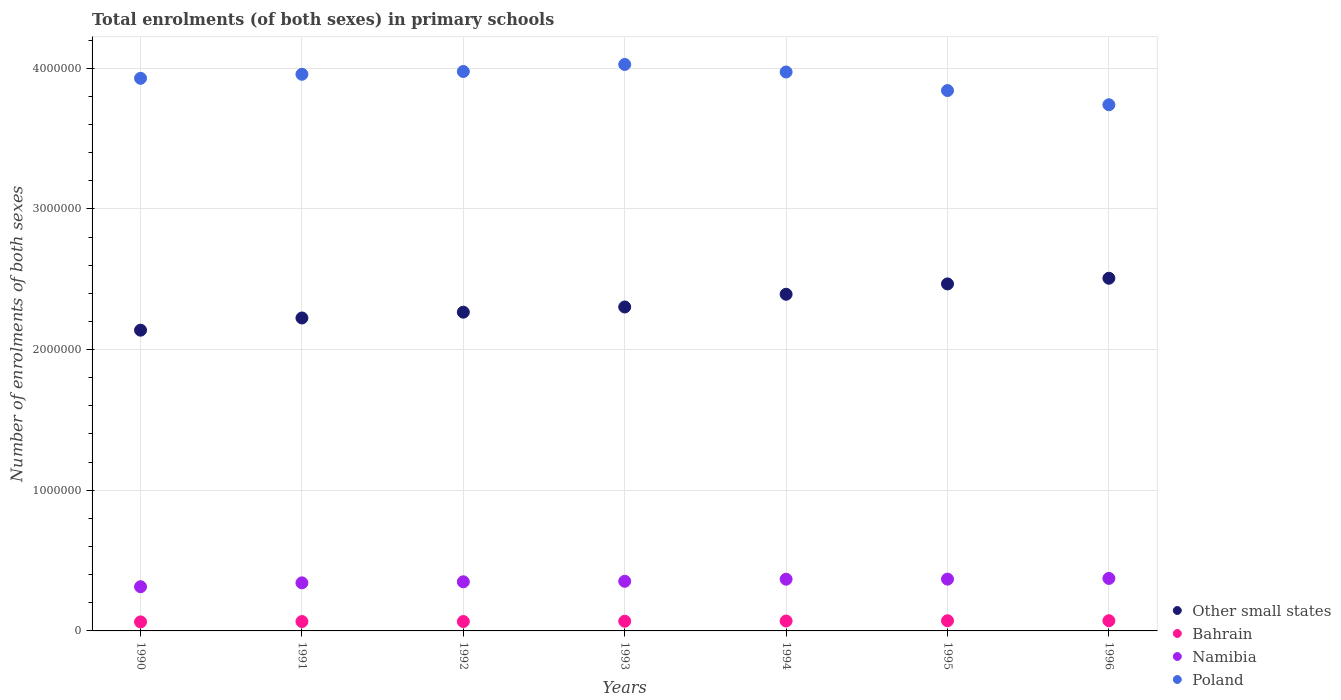How many different coloured dotlines are there?
Offer a terse response. 4. Is the number of dotlines equal to the number of legend labels?
Your answer should be very brief. Yes. What is the number of enrolments in primary schools in Poland in 1992?
Your answer should be very brief. 3.98e+06. Across all years, what is the maximum number of enrolments in primary schools in Namibia?
Keep it short and to the point. 3.73e+05. Across all years, what is the minimum number of enrolments in primary schools in Bahrain?
Ensure brevity in your answer.  6.40e+04. In which year was the number of enrolments in primary schools in Namibia minimum?
Provide a short and direct response. 1990. What is the total number of enrolments in primary schools in Other small states in the graph?
Offer a terse response. 1.63e+07. What is the difference between the number of enrolments in primary schools in Other small states in 1991 and that in 1994?
Your response must be concise. -1.69e+05. What is the difference between the number of enrolments in primary schools in Namibia in 1992 and the number of enrolments in primary schools in Other small states in 1995?
Your response must be concise. -2.12e+06. What is the average number of enrolments in primary schools in Namibia per year?
Provide a short and direct response. 3.52e+05. In the year 1995, what is the difference between the number of enrolments in primary schools in Bahrain and number of enrolments in primary schools in Namibia?
Keep it short and to the point. -2.96e+05. In how many years, is the number of enrolments in primary schools in Other small states greater than 1400000?
Make the answer very short. 7. What is the ratio of the number of enrolments in primary schools in Other small states in 1994 to that in 1996?
Give a very brief answer. 0.95. Is the difference between the number of enrolments in primary schools in Bahrain in 1995 and 1996 greater than the difference between the number of enrolments in primary schools in Namibia in 1995 and 1996?
Give a very brief answer. Yes. What is the difference between the highest and the second highest number of enrolments in primary schools in Bahrain?
Provide a succinct answer. 197. What is the difference between the highest and the lowest number of enrolments in primary schools in Bahrain?
Your answer should be compact. 8526. In how many years, is the number of enrolments in primary schools in Bahrain greater than the average number of enrolments in primary schools in Bahrain taken over all years?
Your response must be concise. 4. Is the sum of the number of enrolments in primary schools in Namibia in 1990 and 1993 greater than the maximum number of enrolments in primary schools in Poland across all years?
Offer a very short reply. No. Is the number of enrolments in primary schools in Bahrain strictly greater than the number of enrolments in primary schools in Other small states over the years?
Make the answer very short. No. Is the number of enrolments in primary schools in Other small states strictly less than the number of enrolments in primary schools in Bahrain over the years?
Ensure brevity in your answer.  No. How many dotlines are there?
Offer a terse response. 4. How many years are there in the graph?
Your answer should be compact. 7. Does the graph contain any zero values?
Make the answer very short. No. Does the graph contain grids?
Ensure brevity in your answer.  Yes. Where does the legend appear in the graph?
Offer a very short reply. Bottom right. What is the title of the graph?
Your answer should be compact. Total enrolments (of both sexes) in primary schools. Does "Curacao" appear as one of the legend labels in the graph?
Your response must be concise. No. What is the label or title of the X-axis?
Keep it short and to the point. Years. What is the label or title of the Y-axis?
Offer a very short reply. Number of enrolments of both sexes. What is the Number of enrolments of both sexes of Other small states in 1990?
Offer a very short reply. 2.14e+06. What is the Number of enrolments of both sexes in Bahrain in 1990?
Give a very brief answer. 6.40e+04. What is the Number of enrolments of both sexes in Namibia in 1990?
Make the answer very short. 3.14e+05. What is the Number of enrolments of both sexes in Poland in 1990?
Your response must be concise. 3.93e+06. What is the Number of enrolments of both sexes in Other small states in 1991?
Make the answer very short. 2.22e+06. What is the Number of enrolments of both sexes of Bahrain in 1991?
Your response must be concise. 6.66e+04. What is the Number of enrolments of both sexes in Namibia in 1991?
Provide a succinct answer. 3.42e+05. What is the Number of enrolments of both sexes in Poland in 1991?
Offer a terse response. 3.96e+06. What is the Number of enrolments of both sexes in Other small states in 1992?
Your answer should be very brief. 2.27e+06. What is the Number of enrolments of both sexes in Bahrain in 1992?
Offer a terse response. 6.67e+04. What is the Number of enrolments of both sexes of Namibia in 1992?
Your answer should be very brief. 3.49e+05. What is the Number of enrolments of both sexes of Poland in 1992?
Provide a short and direct response. 3.98e+06. What is the Number of enrolments of both sexes in Other small states in 1993?
Offer a very short reply. 2.30e+06. What is the Number of enrolments of both sexes in Bahrain in 1993?
Ensure brevity in your answer.  6.89e+04. What is the Number of enrolments of both sexes of Namibia in 1993?
Your answer should be compact. 3.53e+05. What is the Number of enrolments of both sexes of Poland in 1993?
Provide a succinct answer. 4.03e+06. What is the Number of enrolments of both sexes in Other small states in 1994?
Ensure brevity in your answer.  2.39e+06. What is the Number of enrolments of both sexes of Bahrain in 1994?
Keep it short and to the point. 7.05e+04. What is the Number of enrolments of both sexes in Namibia in 1994?
Make the answer very short. 3.68e+05. What is the Number of enrolments of both sexes of Poland in 1994?
Ensure brevity in your answer.  3.97e+06. What is the Number of enrolments of both sexes of Other small states in 1995?
Your response must be concise. 2.47e+06. What is the Number of enrolments of both sexes in Bahrain in 1995?
Your response must be concise. 7.23e+04. What is the Number of enrolments of both sexes in Namibia in 1995?
Your response must be concise. 3.68e+05. What is the Number of enrolments of both sexes in Poland in 1995?
Offer a terse response. 3.84e+06. What is the Number of enrolments of both sexes in Other small states in 1996?
Provide a short and direct response. 2.51e+06. What is the Number of enrolments of both sexes in Bahrain in 1996?
Offer a terse response. 7.25e+04. What is the Number of enrolments of both sexes of Namibia in 1996?
Give a very brief answer. 3.73e+05. What is the Number of enrolments of both sexes of Poland in 1996?
Your answer should be compact. 3.74e+06. Across all years, what is the maximum Number of enrolments of both sexes in Other small states?
Make the answer very short. 2.51e+06. Across all years, what is the maximum Number of enrolments of both sexes in Bahrain?
Your answer should be very brief. 7.25e+04. Across all years, what is the maximum Number of enrolments of both sexes in Namibia?
Provide a succinct answer. 3.73e+05. Across all years, what is the maximum Number of enrolments of both sexes of Poland?
Offer a terse response. 4.03e+06. Across all years, what is the minimum Number of enrolments of both sexes of Other small states?
Offer a terse response. 2.14e+06. Across all years, what is the minimum Number of enrolments of both sexes in Bahrain?
Your answer should be compact. 6.40e+04. Across all years, what is the minimum Number of enrolments of both sexes in Namibia?
Your response must be concise. 3.14e+05. Across all years, what is the minimum Number of enrolments of both sexes of Poland?
Make the answer very short. 3.74e+06. What is the total Number of enrolments of both sexes in Other small states in the graph?
Make the answer very short. 1.63e+07. What is the total Number of enrolments of both sexes in Bahrain in the graph?
Give a very brief answer. 4.82e+05. What is the total Number of enrolments of both sexes in Namibia in the graph?
Make the answer very short. 2.47e+06. What is the total Number of enrolments of both sexes of Poland in the graph?
Your answer should be very brief. 2.74e+07. What is the difference between the Number of enrolments of both sexes of Other small states in 1990 and that in 1991?
Give a very brief answer. -8.66e+04. What is the difference between the Number of enrolments of both sexes in Bahrain in 1990 and that in 1991?
Keep it short and to the point. -2597. What is the difference between the Number of enrolments of both sexes in Namibia in 1990 and that in 1991?
Ensure brevity in your answer.  -2.76e+04. What is the difference between the Number of enrolments of both sexes of Poland in 1990 and that in 1991?
Your answer should be compact. -2.87e+04. What is the difference between the Number of enrolments of both sexes in Other small states in 1990 and that in 1992?
Provide a short and direct response. -1.28e+05. What is the difference between the Number of enrolments of both sexes of Bahrain in 1990 and that in 1992?
Your response must be concise. -2694. What is the difference between the Number of enrolments of both sexes of Namibia in 1990 and that in 1992?
Your answer should be very brief. -3.51e+04. What is the difference between the Number of enrolments of both sexes of Poland in 1990 and that in 1992?
Your response must be concise. -4.83e+04. What is the difference between the Number of enrolments of both sexes of Other small states in 1990 and that in 1993?
Your answer should be compact. -1.65e+05. What is the difference between the Number of enrolments of both sexes in Bahrain in 1990 and that in 1993?
Offer a terse response. -4898. What is the difference between the Number of enrolments of both sexes of Namibia in 1990 and that in 1993?
Give a very brief answer. -3.88e+04. What is the difference between the Number of enrolments of both sexes in Poland in 1990 and that in 1993?
Ensure brevity in your answer.  -9.85e+04. What is the difference between the Number of enrolments of both sexes of Other small states in 1990 and that in 1994?
Make the answer very short. -2.55e+05. What is the difference between the Number of enrolments of both sexes in Bahrain in 1990 and that in 1994?
Offer a very short reply. -6513. What is the difference between the Number of enrolments of both sexes in Namibia in 1990 and that in 1994?
Make the answer very short. -5.36e+04. What is the difference between the Number of enrolments of both sexes of Poland in 1990 and that in 1994?
Your answer should be very brief. -4.49e+04. What is the difference between the Number of enrolments of both sexes of Other small states in 1990 and that in 1995?
Your answer should be compact. -3.29e+05. What is the difference between the Number of enrolments of both sexes in Bahrain in 1990 and that in 1995?
Offer a terse response. -8329. What is the difference between the Number of enrolments of both sexes of Namibia in 1990 and that in 1995?
Ensure brevity in your answer.  -5.41e+04. What is the difference between the Number of enrolments of both sexes of Poland in 1990 and that in 1995?
Keep it short and to the point. 8.71e+04. What is the difference between the Number of enrolments of both sexes of Other small states in 1990 and that in 1996?
Your answer should be very brief. -3.69e+05. What is the difference between the Number of enrolments of both sexes of Bahrain in 1990 and that in 1996?
Make the answer very short. -8526. What is the difference between the Number of enrolments of both sexes in Namibia in 1990 and that in 1996?
Offer a very short reply. -5.92e+04. What is the difference between the Number of enrolments of both sexes of Poland in 1990 and that in 1996?
Offer a very short reply. 1.88e+05. What is the difference between the Number of enrolments of both sexes of Other small states in 1991 and that in 1992?
Provide a succinct answer. -4.13e+04. What is the difference between the Number of enrolments of both sexes in Bahrain in 1991 and that in 1992?
Your answer should be very brief. -97. What is the difference between the Number of enrolments of both sexes in Namibia in 1991 and that in 1992?
Give a very brief answer. -7466. What is the difference between the Number of enrolments of both sexes of Poland in 1991 and that in 1992?
Give a very brief answer. -1.96e+04. What is the difference between the Number of enrolments of both sexes in Other small states in 1991 and that in 1993?
Offer a very short reply. -7.82e+04. What is the difference between the Number of enrolments of both sexes in Bahrain in 1991 and that in 1993?
Your response must be concise. -2301. What is the difference between the Number of enrolments of both sexes in Namibia in 1991 and that in 1993?
Give a very brief answer. -1.12e+04. What is the difference between the Number of enrolments of both sexes of Poland in 1991 and that in 1993?
Provide a short and direct response. -6.98e+04. What is the difference between the Number of enrolments of both sexes of Other small states in 1991 and that in 1994?
Provide a succinct answer. -1.69e+05. What is the difference between the Number of enrolments of both sexes in Bahrain in 1991 and that in 1994?
Provide a succinct answer. -3916. What is the difference between the Number of enrolments of both sexes in Namibia in 1991 and that in 1994?
Provide a succinct answer. -2.60e+04. What is the difference between the Number of enrolments of both sexes in Poland in 1991 and that in 1994?
Provide a succinct answer. -1.62e+04. What is the difference between the Number of enrolments of both sexes in Other small states in 1991 and that in 1995?
Offer a terse response. -2.42e+05. What is the difference between the Number of enrolments of both sexes in Bahrain in 1991 and that in 1995?
Offer a very short reply. -5732. What is the difference between the Number of enrolments of both sexes in Namibia in 1991 and that in 1995?
Offer a very short reply. -2.65e+04. What is the difference between the Number of enrolments of both sexes of Poland in 1991 and that in 1995?
Provide a short and direct response. 1.16e+05. What is the difference between the Number of enrolments of both sexes of Other small states in 1991 and that in 1996?
Ensure brevity in your answer.  -2.82e+05. What is the difference between the Number of enrolments of both sexes in Bahrain in 1991 and that in 1996?
Give a very brief answer. -5929. What is the difference between the Number of enrolments of both sexes of Namibia in 1991 and that in 1996?
Offer a very short reply. -3.16e+04. What is the difference between the Number of enrolments of both sexes of Poland in 1991 and that in 1996?
Keep it short and to the point. 2.17e+05. What is the difference between the Number of enrolments of both sexes of Other small states in 1992 and that in 1993?
Your response must be concise. -3.69e+04. What is the difference between the Number of enrolments of both sexes of Bahrain in 1992 and that in 1993?
Keep it short and to the point. -2204. What is the difference between the Number of enrolments of both sexes in Namibia in 1992 and that in 1993?
Your answer should be compact. -3733. What is the difference between the Number of enrolments of both sexes in Poland in 1992 and that in 1993?
Your answer should be very brief. -5.02e+04. What is the difference between the Number of enrolments of both sexes of Other small states in 1992 and that in 1994?
Provide a succinct answer. -1.27e+05. What is the difference between the Number of enrolments of both sexes of Bahrain in 1992 and that in 1994?
Make the answer very short. -3819. What is the difference between the Number of enrolments of both sexes in Namibia in 1992 and that in 1994?
Your response must be concise. -1.85e+04. What is the difference between the Number of enrolments of both sexes in Poland in 1992 and that in 1994?
Make the answer very short. 3444. What is the difference between the Number of enrolments of both sexes in Other small states in 1992 and that in 1995?
Provide a succinct answer. -2.01e+05. What is the difference between the Number of enrolments of both sexes in Bahrain in 1992 and that in 1995?
Provide a succinct answer. -5635. What is the difference between the Number of enrolments of both sexes in Namibia in 1992 and that in 1995?
Your answer should be very brief. -1.91e+04. What is the difference between the Number of enrolments of both sexes in Poland in 1992 and that in 1995?
Your response must be concise. 1.35e+05. What is the difference between the Number of enrolments of both sexes in Other small states in 1992 and that in 1996?
Provide a succinct answer. -2.41e+05. What is the difference between the Number of enrolments of both sexes of Bahrain in 1992 and that in 1996?
Ensure brevity in your answer.  -5832. What is the difference between the Number of enrolments of both sexes in Namibia in 1992 and that in 1996?
Give a very brief answer. -2.41e+04. What is the difference between the Number of enrolments of both sexes in Poland in 1992 and that in 1996?
Ensure brevity in your answer.  2.36e+05. What is the difference between the Number of enrolments of both sexes in Other small states in 1993 and that in 1994?
Offer a very short reply. -9.05e+04. What is the difference between the Number of enrolments of both sexes of Bahrain in 1993 and that in 1994?
Offer a very short reply. -1615. What is the difference between the Number of enrolments of both sexes of Namibia in 1993 and that in 1994?
Ensure brevity in your answer.  -1.48e+04. What is the difference between the Number of enrolments of both sexes in Poland in 1993 and that in 1994?
Ensure brevity in your answer.  5.36e+04. What is the difference between the Number of enrolments of both sexes in Other small states in 1993 and that in 1995?
Your answer should be compact. -1.64e+05. What is the difference between the Number of enrolments of both sexes in Bahrain in 1993 and that in 1995?
Ensure brevity in your answer.  -3431. What is the difference between the Number of enrolments of both sexes in Namibia in 1993 and that in 1995?
Offer a terse response. -1.53e+04. What is the difference between the Number of enrolments of both sexes of Poland in 1993 and that in 1995?
Keep it short and to the point. 1.86e+05. What is the difference between the Number of enrolments of both sexes of Other small states in 1993 and that in 1996?
Offer a very short reply. -2.04e+05. What is the difference between the Number of enrolments of both sexes of Bahrain in 1993 and that in 1996?
Give a very brief answer. -3628. What is the difference between the Number of enrolments of both sexes in Namibia in 1993 and that in 1996?
Make the answer very short. -2.04e+04. What is the difference between the Number of enrolments of both sexes in Poland in 1993 and that in 1996?
Keep it short and to the point. 2.87e+05. What is the difference between the Number of enrolments of both sexes in Other small states in 1994 and that in 1995?
Keep it short and to the point. -7.35e+04. What is the difference between the Number of enrolments of both sexes in Bahrain in 1994 and that in 1995?
Provide a succinct answer. -1816. What is the difference between the Number of enrolments of both sexes of Namibia in 1994 and that in 1995?
Offer a terse response. -553. What is the difference between the Number of enrolments of both sexes in Poland in 1994 and that in 1995?
Provide a succinct answer. 1.32e+05. What is the difference between the Number of enrolments of both sexes in Other small states in 1994 and that in 1996?
Your response must be concise. -1.14e+05. What is the difference between the Number of enrolments of both sexes in Bahrain in 1994 and that in 1996?
Ensure brevity in your answer.  -2013. What is the difference between the Number of enrolments of both sexes of Namibia in 1994 and that in 1996?
Provide a succinct answer. -5607. What is the difference between the Number of enrolments of both sexes of Poland in 1994 and that in 1996?
Offer a terse response. 2.33e+05. What is the difference between the Number of enrolments of both sexes of Other small states in 1995 and that in 1996?
Provide a succinct answer. -4.03e+04. What is the difference between the Number of enrolments of both sexes of Bahrain in 1995 and that in 1996?
Offer a terse response. -197. What is the difference between the Number of enrolments of both sexes in Namibia in 1995 and that in 1996?
Ensure brevity in your answer.  -5054. What is the difference between the Number of enrolments of both sexes in Poland in 1995 and that in 1996?
Keep it short and to the point. 1.01e+05. What is the difference between the Number of enrolments of both sexes in Other small states in 1990 and the Number of enrolments of both sexes in Bahrain in 1991?
Provide a short and direct response. 2.07e+06. What is the difference between the Number of enrolments of both sexes of Other small states in 1990 and the Number of enrolments of both sexes of Namibia in 1991?
Keep it short and to the point. 1.80e+06. What is the difference between the Number of enrolments of both sexes of Other small states in 1990 and the Number of enrolments of both sexes of Poland in 1991?
Offer a terse response. -1.82e+06. What is the difference between the Number of enrolments of both sexes of Bahrain in 1990 and the Number of enrolments of both sexes of Namibia in 1991?
Offer a terse response. -2.78e+05. What is the difference between the Number of enrolments of both sexes of Bahrain in 1990 and the Number of enrolments of both sexes of Poland in 1991?
Provide a short and direct response. -3.89e+06. What is the difference between the Number of enrolments of both sexes in Namibia in 1990 and the Number of enrolments of both sexes in Poland in 1991?
Your response must be concise. -3.64e+06. What is the difference between the Number of enrolments of both sexes of Other small states in 1990 and the Number of enrolments of both sexes of Bahrain in 1992?
Offer a terse response. 2.07e+06. What is the difference between the Number of enrolments of both sexes of Other small states in 1990 and the Number of enrolments of both sexes of Namibia in 1992?
Make the answer very short. 1.79e+06. What is the difference between the Number of enrolments of both sexes in Other small states in 1990 and the Number of enrolments of both sexes in Poland in 1992?
Ensure brevity in your answer.  -1.84e+06. What is the difference between the Number of enrolments of both sexes in Bahrain in 1990 and the Number of enrolments of both sexes in Namibia in 1992?
Make the answer very short. -2.85e+05. What is the difference between the Number of enrolments of both sexes of Bahrain in 1990 and the Number of enrolments of both sexes of Poland in 1992?
Your response must be concise. -3.91e+06. What is the difference between the Number of enrolments of both sexes of Namibia in 1990 and the Number of enrolments of both sexes of Poland in 1992?
Ensure brevity in your answer.  -3.66e+06. What is the difference between the Number of enrolments of both sexes in Other small states in 1990 and the Number of enrolments of both sexes in Bahrain in 1993?
Provide a short and direct response. 2.07e+06. What is the difference between the Number of enrolments of both sexes of Other small states in 1990 and the Number of enrolments of both sexes of Namibia in 1993?
Offer a terse response. 1.79e+06. What is the difference between the Number of enrolments of both sexes of Other small states in 1990 and the Number of enrolments of both sexes of Poland in 1993?
Ensure brevity in your answer.  -1.89e+06. What is the difference between the Number of enrolments of both sexes of Bahrain in 1990 and the Number of enrolments of both sexes of Namibia in 1993?
Your answer should be very brief. -2.89e+05. What is the difference between the Number of enrolments of both sexes of Bahrain in 1990 and the Number of enrolments of both sexes of Poland in 1993?
Give a very brief answer. -3.96e+06. What is the difference between the Number of enrolments of both sexes of Namibia in 1990 and the Number of enrolments of both sexes of Poland in 1993?
Your response must be concise. -3.71e+06. What is the difference between the Number of enrolments of both sexes of Other small states in 1990 and the Number of enrolments of both sexes of Bahrain in 1994?
Your answer should be compact. 2.07e+06. What is the difference between the Number of enrolments of both sexes of Other small states in 1990 and the Number of enrolments of both sexes of Namibia in 1994?
Your answer should be compact. 1.77e+06. What is the difference between the Number of enrolments of both sexes in Other small states in 1990 and the Number of enrolments of both sexes in Poland in 1994?
Keep it short and to the point. -1.84e+06. What is the difference between the Number of enrolments of both sexes in Bahrain in 1990 and the Number of enrolments of both sexes in Namibia in 1994?
Keep it short and to the point. -3.04e+05. What is the difference between the Number of enrolments of both sexes of Bahrain in 1990 and the Number of enrolments of both sexes of Poland in 1994?
Ensure brevity in your answer.  -3.91e+06. What is the difference between the Number of enrolments of both sexes in Namibia in 1990 and the Number of enrolments of both sexes in Poland in 1994?
Ensure brevity in your answer.  -3.66e+06. What is the difference between the Number of enrolments of both sexes of Other small states in 1990 and the Number of enrolments of both sexes of Bahrain in 1995?
Give a very brief answer. 2.07e+06. What is the difference between the Number of enrolments of both sexes of Other small states in 1990 and the Number of enrolments of both sexes of Namibia in 1995?
Offer a very short reply. 1.77e+06. What is the difference between the Number of enrolments of both sexes in Other small states in 1990 and the Number of enrolments of both sexes in Poland in 1995?
Keep it short and to the point. -1.70e+06. What is the difference between the Number of enrolments of both sexes in Bahrain in 1990 and the Number of enrolments of both sexes in Namibia in 1995?
Make the answer very short. -3.04e+05. What is the difference between the Number of enrolments of both sexes of Bahrain in 1990 and the Number of enrolments of both sexes of Poland in 1995?
Your answer should be very brief. -3.78e+06. What is the difference between the Number of enrolments of both sexes of Namibia in 1990 and the Number of enrolments of both sexes of Poland in 1995?
Give a very brief answer. -3.53e+06. What is the difference between the Number of enrolments of both sexes of Other small states in 1990 and the Number of enrolments of both sexes of Bahrain in 1996?
Ensure brevity in your answer.  2.07e+06. What is the difference between the Number of enrolments of both sexes of Other small states in 1990 and the Number of enrolments of both sexes of Namibia in 1996?
Provide a succinct answer. 1.76e+06. What is the difference between the Number of enrolments of both sexes in Other small states in 1990 and the Number of enrolments of both sexes in Poland in 1996?
Give a very brief answer. -1.60e+06. What is the difference between the Number of enrolments of both sexes of Bahrain in 1990 and the Number of enrolments of both sexes of Namibia in 1996?
Give a very brief answer. -3.09e+05. What is the difference between the Number of enrolments of both sexes in Bahrain in 1990 and the Number of enrolments of both sexes in Poland in 1996?
Ensure brevity in your answer.  -3.68e+06. What is the difference between the Number of enrolments of both sexes of Namibia in 1990 and the Number of enrolments of both sexes of Poland in 1996?
Make the answer very short. -3.43e+06. What is the difference between the Number of enrolments of both sexes in Other small states in 1991 and the Number of enrolments of both sexes in Bahrain in 1992?
Keep it short and to the point. 2.16e+06. What is the difference between the Number of enrolments of both sexes of Other small states in 1991 and the Number of enrolments of both sexes of Namibia in 1992?
Your response must be concise. 1.88e+06. What is the difference between the Number of enrolments of both sexes of Other small states in 1991 and the Number of enrolments of both sexes of Poland in 1992?
Provide a short and direct response. -1.75e+06. What is the difference between the Number of enrolments of both sexes of Bahrain in 1991 and the Number of enrolments of both sexes of Namibia in 1992?
Offer a terse response. -2.83e+05. What is the difference between the Number of enrolments of both sexes in Bahrain in 1991 and the Number of enrolments of both sexes in Poland in 1992?
Your response must be concise. -3.91e+06. What is the difference between the Number of enrolments of both sexes of Namibia in 1991 and the Number of enrolments of both sexes of Poland in 1992?
Provide a short and direct response. -3.64e+06. What is the difference between the Number of enrolments of both sexes in Other small states in 1991 and the Number of enrolments of both sexes in Bahrain in 1993?
Make the answer very short. 2.16e+06. What is the difference between the Number of enrolments of both sexes in Other small states in 1991 and the Number of enrolments of both sexes in Namibia in 1993?
Offer a very short reply. 1.87e+06. What is the difference between the Number of enrolments of both sexes of Other small states in 1991 and the Number of enrolments of both sexes of Poland in 1993?
Ensure brevity in your answer.  -1.80e+06. What is the difference between the Number of enrolments of both sexes of Bahrain in 1991 and the Number of enrolments of both sexes of Namibia in 1993?
Provide a short and direct response. -2.86e+05. What is the difference between the Number of enrolments of both sexes in Bahrain in 1991 and the Number of enrolments of both sexes in Poland in 1993?
Provide a succinct answer. -3.96e+06. What is the difference between the Number of enrolments of both sexes of Namibia in 1991 and the Number of enrolments of both sexes of Poland in 1993?
Your answer should be compact. -3.69e+06. What is the difference between the Number of enrolments of both sexes in Other small states in 1991 and the Number of enrolments of both sexes in Bahrain in 1994?
Keep it short and to the point. 2.15e+06. What is the difference between the Number of enrolments of both sexes in Other small states in 1991 and the Number of enrolments of both sexes in Namibia in 1994?
Make the answer very short. 1.86e+06. What is the difference between the Number of enrolments of both sexes of Other small states in 1991 and the Number of enrolments of both sexes of Poland in 1994?
Ensure brevity in your answer.  -1.75e+06. What is the difference between the Number of enrolments of both sexes in Bahrain in 1991 and the Number of enrolments of both sexes in Namibia in 1994?
Ensure brevity in your answer.  -3.01e+05. What is the difference between the Number of enrolments of both sexes in Bahrain in 1991 and the Number of enrolments of both sexes in Poland in 1994?
Offer a very short reply. -3.91e+06. What is the difference between the Number of enrolments of both sexes of Namibia in 1991 and the Number of enrolments of both sexes of Poland in 1994?
Provide a short and direct response. -3.63e+06. What is the difference between the Number of enrolments of both sexes in Other small states in 1991 and the Number of enrolments of both sexes in Bahrain in 1995?
Ensure brevity in your answer.  2.15e+06. What is the difference between the Number of enrolments of both sexes of Other small states in 1991 and the Number of enrolments of both sexes of Namibia in 1995?
Ensure brevity in your answer.  1.86e+06. What is the difference between the Number of enrolments of both sexes in Other small states in 1991 and the Number of enrolments of both sexes in Poland in 1995?
Ensure brevity in your answer.  -1.62e+06. What is the difference between the Number of enrolments of both sexes in Bahrain in 1991 and the Number of enrolments of both sexes in Namibia in 1995?
Make the answer very short. -3.02e+05. What is the difference between the Number of enrolments of both sexes of Bahrain in 1991 and the Number of enrolments of both sexes of Poland in 1995?
Ensure brevity in your answer.  -3.77e+06. What is the difference between the Number of enrolments of both sexes in Namibia in 1991 and the Number of enrolments of both sexes in Poland in 1995?
Provide a short and direct response. -3.50e+06. What is the difference between the Number of enrolments of both sexes of Other small states in 1991 and the Number of enrolments of both sexes of Bahrain in 1996?
Your response must be concise. 2.15e+06. What is the difference between the Number of enrolments of both sexes of Other small states in 1991 and the Number of enrolments of both sexes of Namibia in 1996?
Ensure brevity in your answer.  1.85e+06. What is the difference between the Number of enrolments of both sexes in Other small states in 1991 and the Number of enrolments of both sexes in Poland in 1996?
Provide a succinct answer. -1.52e+06. What is the difference between the Number of enrolments of both sexes of Bahrain in 1991 and the Number of enrolments of both sexes of Namibia in 1996?
Your answer should be very brief. -3.07e+05. What is the difference between the Number of enrolments of both sexes in Bahrain in 1991 and the Number of enrolments of both sexes in Poland in 1996?
Your answer should be compact. -3.67e+06. What is the difference between the Number of enrolments of both sexes of Namibia in 1991 and the Number of enrolments of both sexes of Poland in 1996?
Make the answer very short. -3.40e+06. What is the difference between the Number of enrolments of both sexes in Other small states in 1992 and the Number of enrolments of both sexes in Bahrain in 1993?
Ensure brevity in your answer.  2.20e+06. What is the difference between the Number of enrolments of both sexes of Other small states in 1992 and the Number of enrolments of both sexes of Namibia in 1993?
Ensure brevity in your answer.  1.91e+06. What is the difference between the Number of enrolments of both sexes of Other small states in 1992 and the Number of enrolments of both sexes of Poland in 1993?
Provide a succinct answer. -1.76e+06. What is the difference between the Number of enrolments of both sexes in Bahrain in 1992 and the Number of enrolments of both sexes in Namibia in 1993?
Offer a terse response. -2.86e+05. What is the difference between the Number of enrolments of both sexes of Bahrain in 1992 and the Number of enrolments of both sexes of Poland in 1993?
Offer a terse response. -3.96e+06. What is the difference between the Number of enrolments of both sexes of Namibia in 1992 and the Number of enrolments of both sexes of Poland in 1993?
Keep it short and to the point. -3.68e+06. What is the difference between the Number of enrolments of both sexes of Other small states in 1992 and the Number of enrolments of both sexes of Bahrain in 1994?
Offer a terse response. 2.20e+06. What is the difference between the Number of enrolments of both sexes in Other small states in 1992 and the Number of enrolments of both sexes in Namibia in 1994?
Your answer should be compact. 1.90e+06. What is the difference between the Number of enrolments of both sexes of Other small states in 1992 and the Number of enrolments of both sexes of Poland in 1994?
Provide a short and direct response. -1.71e+06. What is the difference between the Number of enrolments of both sexes in Bahrain in 1992 and the Number of enrolments of both sexes in Namibia in 1994?
Keep it short and to the point. -3.01e+05. What is the difference between the Number of enrolments of both sexes in Bahrain in 1992 and the Number of enrolments of both sexes in Poland in 1994?
Offer a terse response. -3.91e+06. What is the difference between the Number of enrolments of both sexes of Namibia in 1992 and the Number of enrolments of both sexes of Poland in 1994?
Your answer should be very brief. -3.62e+06. What is the difference between the Number of enrolments of both sexes of Other small states in 1992 and the Number of enrolments of both sexes of Bahrain in 1995?
Ensure brevity in your answer.  2.19e+06. What is the difference between the Number of enrolments of both sexes in Other small states in 1992 and the Number of enrolments of both sexes in Namibia in 1995?
Offer a terse response. 1.90e+06. What is the difference between the Number of enrolments of both sexes in Other small states in 1992 and the Number of enrolments of both sexes in Poland in 1995?
Offer a very short reply. -1.58e+06. What is the difference between the Number of enrolments of both sexes in Bahrain in 1992 and the Number of enrolments of both sexes in Namibia in 1995?
Ensure brevity in your answer.  -3.02e+05. What is the difference between the Number of enrolments of both sexes in Bahrain in 1992 and the Number of enrolments of both sexes in Poland in 1995?
Give a very brief answer. -3.77e+06. What is the difference between the Number of enrolments of both sexes of Namibia in 1992 and the Number of enrolments of both sexes of Poland in 1995?
Offer a very short reply. -3.49e+06. What is the difference between the Number of enrolments of both sexes of Other small states in 1992 and the Number of enrolments of both sexes of Bahrain in 1996?
Your response must be concise. 2.19e+06. What is the difference between the Number of enrolments of both sexes in Other small states in 1992 and the Number of enrolments of both sexes in Namibia in 1996?
Your answer should be very brief. 1.89e+06. What is the difference between the Number of enrolments of both sexes in Other small states in 1992 and the Number of enrolments of both sexes in Poland in 1996?
Your answer should be very brief. -1.47e+06. What is the difference between the Number of enrolments of both sexes of Bahrain in 1992 and the Number of enrolments of both sexes of Namibia in 1996?
Your answer should be very brief. -3.07e+05. What is the difference between the Number of enrolments of both sexes in Bahrain in 1992 and the Number of enrolments of both sexes in Poland in 1996?
Give a very brief answer. -3.67e+06. What is the difference between the Number of enrolments of both sexes in Namibia in 1992 and the Number of enrolments of both sexes in Poland in 1996?
Your response must be concise. -3.39e+06. What is the difference between the Number of enrolments of both sexes in Other small states in 1993 and the Number of enrolments of both sexes in Bahrain in 1994?
Provide a short and direct response. 2.23e+06. What is the difference between the Number of enrolments of both sexes of Other small states in 1993 and the Number of enrolments of both sexes of Namibia in 1994?
Keep it short and to the point. 1.94e+06. What is the difference between the Number of enrolments of both sexes in Other small states in 1993 and the Number of enrolments of both sexes in Poland in 1994?
Offer a very short reply. -1.67e+06. What is the difference between the Number of enrolments of both sexes in Bahrain in 1993 and the Number of enrolments of both sexes in Namibia in 1994?
Make the answer very short. -2.99e+05. What is the difference between the Number of enrolments of both sexes in Bahrain in 1993 and the Number of enrolments of both sexes in Poland in 1994?
Ensure brevity in your answer.  -3.90e+06. What is the difference between the Number of enrolments of both sexes in Namibia in 1993 and the Number of enrolments of both sexes in Poland in 1994?
Your answer should be very brief. -3.62e+06. What is the difference between the Number of enrolments of both sexes of Other small states in 1993 and the Number of enrolments of both sexes of Bahrain in 1995?
Provide a succinct answer. 2.23e+06. What is the difference between the Number of enrolments of both sexes of Other small states in 1993 and the Number of enrolments of both sexes of Namibia in 1995?
Ensure brevity in your answer.  1.93e+06. What is the difference between the Number of enrolments of both sexes in Other small states in 1993 and the Number of enrolments of both sexes in Poland in 1995?
Offer a terse response. -1.54e+06. What is the difference between the Number of enrolments of both sexes in Bahrain in 1993 and the Number of enrolments of both sexes in Namibia in 1995?
Keep it short and to the point. -2.99e+05. What is the difference between the Number of enrolments of both sexes in Bahrain in 1993 and the Number of enrolments of both sexes in Poland in 1995?
Ensure brevity in your answer.  -3.77e+06. What is the difference between the Number of enrolments of both sexes of Namibia in 1993 and the Number of enrolments of both sexes of Poland in 1995?
Ensure brevity in your answer.  -3.49e+06. What is the difference between the Number of enrolments of both sexes of Other small states in 1993 and the Number of enrolments of both sexes of Bahrain in 1996?
Offer a very short reply. 2.23e+06. What is the difference between the Number of enrolments of both sexes of Other small states in 1993 and the Number of enrolments of both sexes of Namibia in 1996?
Your response must be concise. 1.93e+06. What is the difference between the Number of enrolments of both sexes in Other small states in 1993 and the Number of enrolments of both sexes in Poland in 1996?
Give a very brief answer. -1.44e+06. What is the difference between the Number of enrolments of both sexes of Bahrain in 1993 and the Number of enrolments of both sexes of Namibia in 1996?
Your response must be concise. -3.04e+05. What is the difference between the Number of enrolments of both sexes in Bahrain in 1993 and the Number of enrolments of both sexes in Poland in 1996?
Your response must be concise. -3.67e+06. What is the difference between the Number of enrolments of both sexes of Namibia in 1993 and the Number of enrolments of both sexes of Poland in 1996?
Offer a very short reply. -3.39e+06. What is the difference between the Number of enrolments of both sexes in Other small states in 1994 and the Number of enrolments of both sexes in Bahrain in 1995?
Your answer should be very brief. 2.32e+06. What is the difference between the Number of enrolments of both sexes of Other small states in 1994 and the Number of enrolments of both sexes of Namibia in 1995?
Offer a very short reply. 2.03e+06. What is the difference between the Number of enrolments of both sexes in Other small states in 1994 and the Number of enrolments of both sexes in Poland in 1995?
Your response must be concise. -1.45e+06. What is the difference between the Number of enrolments of both sexes of Bahrain in 1994 and the Number of enrolments of both sexes of Namibia in 1995?
Ensure brevity in your answer.  -2.98e+05. What is the difference between the Number of enrolments of both sexes in Bahrain in 1994 and the Number of enrolments of both sexes in Poland in 1995?
Provide a succinct answer. -3.77e+06. What is the difference between the Number of enrolments of both sexes of Namibia in 1994 and the Number of enrolments of both sexes of Poland in 1995?
Keep it short and to the point. -3.47e+06. What is the difference between the Number of enrolments of both sexes of Other small states in 1994 and the Number of enrolments of both sexes of Bahrain in 1996?
Provide a succinct answer. 2.32e+06. What is the difference between the Number of enrolments of both sexes of Other small states in 1994 and the Number of enrolments of both sexes of Namibia in 1996?
Your answer should be compact. 2.02e+06. What is the difference between the Number of enrolments of both sexes in Other small states in 1994 and the Number of enrolments of both sexes in Poland in 1996?
Make the answer very short. -1.35e+06. What is the difference between the Number of enrolments of both sexes of Bahrain in 1994 and the Number of enrolments of both sexes of Namibia in 1996?
Give a very brief answer. -3.03e+05. What is the difference between the Number of enrolments of both sexes in Bahrain in 1994 and the Number of enrolments of both sexes in Poland in 1996?
Your answer should be very brief. -3.67e+06. What is the difference between the Number of enrolments of both sexes of Namibia in 1994 and the Number of enrolments of both sexes of Poland in 1996?
Ensure brevity in your answer.  -3.37e+06. What is the difference between the Number of enrolments of both sexes in Other small states in 1995 and the Number of enrolments of both sexes in Bahrain in 1996?
Give a very brief answer. 2.39e+06. What is the difference between the Number of enrolments of both sexes in Other small states in 1995 and the Number of enrolments of both sexes in Namibia in 1996?
Your answer should be very brief. 2.09e+06. What is the difference between the Number of enrolments of both sexes of Other small states in 1995 and the Number of enrolments of both sexes of Poland in 1996?
Make the answer very short. -1.27e+06. What is the difference between the Number of enrolments of both sexes of Bahrain in 1995 and the Number of enrolments of both sexes of Namibia in 1996?
Your response must be concise. -3.01e+05. What is the difference between the Number of enrolments of both sexes of Bahrain in 1995 and the Number of enrolments of both sexes of Poland in 1996?
Make the answer very short. -3.67e+06. What is the difference between the Number of enrolments of both sexes of Namibia in 1995 and the Number of enrolments of both sexes of Poland in 1996?
Make the answer very short. -3.37e+06. What is the average Number of enrolments of both sexes in Other small states per year?
Make the answer very short. 2.33e+06. What is the average Number of enrolments of both sexes in Bahrain per year?
Offer a terse response. 6.88e+04. What is the average Number of enrolments of both sexes of Namibia per year?
Make the answer very short. 3.52e+05. What is the average Number of enrolments of both sexes in Poland per year?
Give a very brief answer. 3.92e+06. In the year 1990, what is the difference between the Number of enrolments of both sexes of Other small states and Number of enrolments of both sexes of Bahrain?
Give a very brief answer. 2.07e+06. In the year 1990, what is the difference between the Number of enrolments of both sexes in Other small states and Number of enrolments of both sexes in Namibia?
Offer a very short reply. 1.82e+06. In the year 1990, what is the difference between the Number of enrolments of both sexes of Other small states and Number of enrolments of both sexes of Poland?
Keep it short and to the point. -1.79e+06. In the year 1990, what is the difference between the Number of enrolments of both sexes of Bahrain and Number of enrolments of both sexes of Namibia?
Your response must be concise. -2.50e+05. In the year 1990, what is the difference between the Number of enrolments of both sexes in Bahrain and Number of enrolments of both sexes in Poland?
Ensure brevity in your answer.  -3.86e+06. In the year 1990, what is the difference between the Number of enrolments of both sexes of Namibia and Number of enrolments of both sexes of Poland?
Keep it short and to the point. -3.61e+06. In the year 1991, what is the difference between the Number of enrolments of both sexes of Other small states and Number of enrolments of both sexes of Bahrain?
Your response must be concise. 2.16e+06. In the year 1991, what is the difference between the Number of enrolments of both sexes in Other small states and Number of enrolments of both sexes in Namibia?
Offer a terse response. 1.88e+06. In the year 1991, what is the difference between the Number of enrolments of both sexes of Other small states and Number of enrolments of both sexes of Poland?
Your answer should be very brief. -1.73e+06. In the year 1991, what is the difference between the Number of enrolments of both sexes of Bahrain and Number of enrolments of both sexes of Namibia?
Make the answer very short. -2.75e+05. In the year 1991, what is the difference between the Number of enrolments of both sexes in Bahrain and Number of enrolments of both sexes in Poland?
Give a very brief answer. -3.89e+06. In the year 1991, what is the difference between the Number of enrolments of both sexes in Namibia and Number of enrolments of both sexes in Poland?
Offer a terse response. -3.62e+06. In the year 1992, what is the difference between the Number of enrolments of both sexes in Other small states and Number of enrolments of both sexes in Bahrain?
Offer a very short reply. 2.20e+06. In the year 1992, what is the difference between the Number of enrolments of both sexes of Other small states and Number of enrolments of both sexes of Namibia?
Make the answer very short. 1.92e+06. In the year 1992, what is the difference between the Number of enrolments of both sexes in Other small states and Number of enrolments of both sexes in Poland?
Your answer should be compact. -1.71e+06. In the year 1992, what is the difference between the Number of enrolments of both sexes of Bahrain and Number of enrolments of both sexes of Namibia?
Your answer should be very brief. -2.82e+05. In the year 1992, what is the difference between the Number of enrolments of both sexes in Bahrain and Number of enrolments of both sexes in Poland?
Make the answer very short. -3.91e+06. In the year 1992, what is the difference between the Number of enrolments of both sexes of Namibia and Number of enrolments of both sexes of Poland?
Provide a short and direct response. -3.63e+06. In the year 1993, what is the difference between the Number of enrolments of both sexes of Other small states and Number of enrolments of both sexes of Bahrain?
Offer a terse response. 2.23e+06. In the year 1993, what is the difference between the Number of enrolments of both sexes in Other small states and Number of enrolments of both sexes in Namibia?
Ensure brevity in your answer.  1.95e+06. In the year 1993, what is the difference between the Number of enrolments of both sexes in Other small states and Number of enrolments of both sexes in Poland?
Your response must be concise. -1.72e+06. In the year 1993, what is the difference between the Number of enrolments of both sexes of Bahrain and Number of enrolments of both sexes of Namibia?
Provide a succinct answer. -2.84e+05. In the year 1993, what is the difference between the Number of enrolments of both sexes in Bahrain and Number of enrolments of both sexes in Poland?
Provide a short and direct response. -3.96e+06. In the year 1993, what is the difference between the Number of enrolments of both sexes of Namibia and Number of enrolments of both sexes of Poland?
Keep it short and to the point. -3.67e+06. In the year 1994, what is the difference between the Number of enrolments of both sexes of Other small states and Number of enrolments of both sexes of Bahrain?
Your answer should be compact. 2.32e+06. In the year 1994, what is the difference between the Number of enrolments of both sexes in Other small states and Number of enrolments of both sexes in Namibia?
Make the answer very short. 2.03e+06. In the year 1994, what is the difference between the Number of enrolments of both sexes of Other small states and Number of enrolments of both sexes of Poland?
Ensure brevity in your answer.  -1.58e+06. In the year 1994, what is the difference between the Number of enrolments of both sexes in Bahrain and Number of enrolments of both sexes in Namibia?
Make the answer very short. -2.97e+05. In the year 1994, what is the difference between the Number of enrolments of both sexes of Bahrain and Number of enrolments of both sexes of Poland?
Offer a very short reply. -3.90e+06. In the year 1994, what is the difference between the Number of enrolments of both sexes in Namibia and Number of enrolments of both sexes in Poland?
Your response must be concise. -3.61e+06. In the year 1995, what is the difference between the Number of enrolments of both sexes in Other small states and Number of enrolments of both sexes in Bahrain?
Offer a very short reply. 2.39e+06. In the year 1995, what is the difference between the Number of enrolments of both sexes of Other small states and Number of enrolments of both sexes of Namibia?
Offer a terse response. 2.10e+06. In the year 1995, what is the difference between the Number of enrolments of both sexes of Other small states and Number of enrolments of both sexes of Poland?
Your answer should be very brief. -1.37e+06. In the year 1995, what is the difference between the Number of enrolments of both sexes in Bahrain and Number of enrolments of both sexes in Namibia?
Offer a very short reply. -2.96e+05. In the year 1995, what is the difference between the Number of enrolments of both sexes of Bahrain and Number of enrolments of both sexes of Poland?
Make the answer very short. -3.77e+06. In the year 1995, what is the difference between the Number of enrolments of both sexes in Namibia and Number of enrolments of both sexes in Poland?
Your response must be concise. -3.47e+06. In the year 1996, what is the difference between the Number of enrolments of both sexes in Other small states and Number of enrolments of both sexes in Bahrain?
Offer a terse response. 2.43e+06. In the year 1996, what is the difference between the Number of enrolments of both sexes of Other small states and Number of enrolments of both sexes of Namibia?
Ensure brevity in your answer.  2.13e+06. In the year 1996, what is the difference between the Number of enrolments of both sexes of Other small states and Number of enrolments of both sexes of Poland?
Provide a short and direct response. -1.23e+06. In the year 1996, what is the difference between the Number of enrolments of both sexes in Bahrain and Number of enrolments of both sexes in Namibia?
Your response must be concise. -3.01e+05. In the year 1996, what is the difference between the Number of enrolments of both sexes of Bahrain and Number of enrolments of both sexes of Poland?
Give a very brief answer. -3.67e+06. In the year 1996, what is the difference between the Number of enrolments of both sexes in Namibia and Number of enrolments of both sexes in Poland?
Your answer should be very brief. -3.37e+06. What is the ratio of the Number of enrolments of both sexes of Other small states in 1990 to that in 1991?
Offer a very short reply. 0.96. What is the ratio of the Number of enrolments of both sexes of Bahrain in 1990 to that in 1991?
Your response must be concise. 0.96. What is the ratio of the Number of enrolments of both sexes in Namibia in 1990 to that in 1991?
Offer a very short reply. 0.92. What is the ratio of the Number of enrolments of both sexes in Other small states in 1990 to that in 1992?
Provide a succinct answer. 0.94. What is the ratio of the Number of enrolments of both sexes in Bahrain in 1990 to that in 1992?
Your answer should be very brief. 0.96. What is the ratio of the Number of enrolments of both sexes in Namibia in 1990 to that in 1992?
Offer a very short reply. 0.9. What is the ratio of the Number of enrolments of both sexes of Poland in 1990 to that in 1992?
Your answer should be very brief. 0.99. What is the ratio of the Number of enrolments of both sexes in Other small states in 1990 to that in 1993?
Your response must be concise. 0.93. What is the ratio of the Number of enrolments of both sexes of Bahrain in 1990 to that in 1993?
Ensure brevity in your answer.  0.93. What is the ratio of the Number of enrolments of both sexes of Namibia in 1990 to that in 1993?
Your response must be concise. 0.89. What is the ratio of the Number of enrolments of both sexes in Poland in 1990 to that in 1993?
Your answer should be compact. 0.98. What is the ratio of the Number of enrolments of both sexes of Other small states in 1990 to that in 1994?
Offer a terse response. 0.89. What is the ratio of the Number of enrolments of both sexes of Bahrain in 1990 to that in 1994?
Provide a short and direct response. 0.91. What is the ratio of the Number of enrolments of both sexes of Namibia in 1990 to that in 1994?
Your response must be concise. 0.85. What is the ratio of the Number of enrolments of both sexes in Poland in 1990 to that in 1994?
Offer a very short reply. 0.99. What is the ratio of the Number of enrolments of both sexes in Other small states in 1990 to that in 1995?
Ensure brevity in your answer.  0.87. What is the ratio of the Number of enrolments of both sexes of Bahrain in 1990 to that in 1995?
Provide a short and direct response. 0.88. What is the ratio of the Number of enrolments of both sexes of Namibia in 1990 to that in 1995?
Keep it short and to the point. 0.85. What is the ratio of the Number of enrolments of both sexes of Poland in 1990 to that in 1995?
Your response must be concise. 1.02. What is the ratio of the Number of enrolments of both sexes of Other small states in 1990 to that in 1996?
Make the answer very short. 0.85. What is the ratio of the Number of enrolments of both sexes in Bahrain in 1990 to that in 1996?
Ensure brevity in your answer.  0.88. What is the ratio of the Number of enrolments of both sexes in Namibia in 1990 to that in 1996?
Give a very brief answer. 0.84. What is the ratio of the Number of enrolments of both sexes in Poland in 1990 to that in 1996?
Keep it short and to the point. 1.05. What is the ratio of the Number of enrolments of both sexes in Other small states in 1991 to that in 1992?
Your answer should be very brief. 0.98. What is the ratio of the Number of enrolments of both sexes in Bahrain in 1991 to that in 1992?
Make the answer very short. 1. What is the ratio of the Number of enrolments of both sexes of Namibia in 1991 to that in 1992?
Offer a terse response. 0.98. What is the ratio of the Number of enrolments of both sexes in Poland in 1991 to that in 1992?
Keep it short and to the point. 1. What is the ratio of the Number of enrolments of both sexes in Other small states in 1991 to that in 1993?
Make the answer very short. 0.97. What is the ratio of the Number of enrolments of both sexes of Bahrain in 1991 to that in 1993?
Your answer should be compact. 0.97. What is the ratio of the Number of enrolments of both sexes of Namibia in 1991 to that in 1993?
Your response must be concise. 0.97. What is the ratio of the Number of enrolments of both sexes of Poland in 1991 to that in 1993?
Offer a terse response. 0.98. What is the ratio of the Number of enrolments of both sexes in Other small states in 1991 to that in 1994?
Provide a short and direct response. 0.93. What is the ratio of the Number of enrolments of both sexes in Bahrain in 1991 to that in 1994?
Make the answer very short. 0.94. What is the ratio of the Number of enrolments of both sexes in Namibia in 1991 to that in 1994?
Keep it short and to the point. 0.93. What is the ratio of the Number of enrolments of both sexes of Other small states in 1991 to that in 1995?
Make the answer very short. 0.9. What is the ratio of the Number of enrolments of both sexes in Bahrain in 1991 to that in 1995?
Provide a succinct answer. 0.92. What is the ratio of the Number of enrolments of both sexes in Namibia in 1991 to that in 1995?
Offer a terse response. 0.93. What is the ratio of the Number of enrolments of both sexes of Poland in 1991 to that in 1995?
Keep it short and to the point. 1.03. What is the ratio of the Number of enrolments of both sexes of Other small states in 1991 to that in 1996?
Your response must be concise. 0.89. What is the ratio of the Number of enrolments of both sexes in Bahrain in 1991 to that in 1996?
Your response must be concise. 0.92. What is the ratio of the Number of enrolments of both sexes in Namibia in 1991 to that in 1996?
Provide a succinct answer. 0.92. What is the ratio of the Number of enrolments of both sexes of Poland in 1991 to that in 1996?
Your answer should be compact. 1.06. What is the ratio of the Number of enrolments of both sexes in Other small states in 1992 to that in 1993?
Your response must be concise. 0.98. What is the ratio of the Number of enrolments of both sexes in Namibia in 1992 to that in 1993?
Your answer should be very brief. 0.99. What is the ratio of the Number of enrolments of both sexes in Poland in 1992 to that in 1993?
Make the answer very short. 0.99. What is the ratio of the Number of enrolments of both sexes in Other small states in 1992 to that in 1994?
Your response must be concise. 0.95. What is the ratio of the Number of enrolments of both sexes of Bahrain in 1992 to that in 1994?
Ensure brevity in your answer.  0.95. What is the ratio of the Number of enrolments of both sexes of Namibia in 1992 to that in 1994?
Your response must be concise. 0.95. What is the ratio of the Number of enrolments of both sexes of Other small states in 1992 to that in 1995?
Your answer should be compact. 0.92. What is the ratio of the Number of enrolments of both sexes in Bahrain in 1992 to that in 1995?
Your answer should be compact. 0.92. What is the ratio of the Number of enrolments of both sexes of Namibia in 1992 to that in 1995?
Provide a short and direct response. 0.95. What is the ratio of the Number of enrolments of both sexes of Poland in 1992 to that in 1995?
Give a very brief answer. 1.04. What is the ratio of the Number of enrolments of both sexes of Other small states in 1992 to that in 1996?
Ensure brevity in your answer.  0.9. What is the ratio of the Number of enrolments of both sexes in Bahrain in 1992 to that in 1996?
Offer a very short reply. 0.92. What is the ratio of the Number of enrolments of both sexes in Namibia in 1992 to that in 1996?
Ensure brevity in your answer.  0.94. What is the ratio of the Number of enrolments of both sexes in Poland in 1992 to that in 1996?
Your answer should be very brief. 1.06. What is the ratio of the Number of enrolments of both sexes of Other small states in 1993 to that in 1994?
Offer a very short reply. 0.96. What is the ratio of the Number of enrolments of both sexes of Bahrain in 1993 to that in 1994?
Ensure brevity in your answer.  0.98. What is the ratio of the Number of enrolments of both sexes in Namibia in 1993 to that in 1994?
Offer a very short reply. 0.96. What is the ratio of the Number of enrolments of both sexes of Poland in 1993 to that in 1994?
Give a very brief answer. 1.01. What is the ratio of the Number of enrolments of both sexes in Other small states in 1993 to that in 1995?
Provide a succinct answer. 0.93. What is the ratio of the Number of enrolments of both sexes of Bahrain in 1993 to that in 1995?
Ensure brevity in your answer.  0.95. What is the ratio of the Number of enrolments of both sexes in Namibia in 1993 to that in 1995?
Your response must be concise. 0.96. What is the ratio of the Number of enrolments of both sexes in Poland in 1993 to that in 1995?
Give a very brief answer. 1.05. What is the ratio of the Number of enrolments of both sexes in Other small states in 1993 to that in 1996?
Provide a succinct answer. 0.92. What is the ratio of the Number of enrolments of both sexes in Namibia in 1993 to that in 1996?
Your response must be concise. 0.95. What is the ratio of the Number of enrolments of both sexes in Poland in 1993 to that in 1996?
Offer a terse response. 1.08. What is the ratio of the Number of enrolments of both sexes in Other small states in 1994 to that in 1995?
Provide a short and direct response. 0.97. What is the ratio of the Number of enrolments of both sexes of Bahrain in 1994 to that in 1995?
Ensure brevity in your answer.  0.97. What is the ratio of the Number of enrolments of both sexes in Poland in 1994 to that in 1995?
Your answer should be very brief. 1.03. What is the ratio of the Number of enrolments of both sexes in Other small states in 1994 to that in 1996?
Keep it short and to the point. 0.95. What is the ratio of the Number of enrolments of both sexes in Bahrain in 1994 to that in 1996?
Give a very brief answer. 0.97. What is the ratio of the Number of enrolments of both sexes in Namibia in 1994 to that in 1996?
Keep it short and to the point. 0.98. What is the ratio of the Number of enrolments of both sexes of Poland in 1994 to that in 1996?
Your answer should be compact. 1.06. What is the ratio of the Number of enrolments of both sexes in Other small states in 1995 to that in 1996?
Offer a very short reply. 0.98. What is the ratio of the Number of enrolments of both sexes in Bahrain in 1995 to that in 1996?
Your response must be concise. 1. What is the ratio of the Number of enrolments of both sexes of Namibia in 1995 to that in 1996?
Provide a succinct answer. 0.99. What is the difference between the highest and the second highest Number of enrolments of both sexes in Other small states?
Ensure brevity in your answer.  4.03e+04. What is the difference between the highest and the second highest Number of enrolments of both sexes in Bahrain?
Provide a short and direct response. 197. What is the difference between the highest and the second highest Number of enrolments of both sexes in Namibia?
Your response must be concise. 5054. What is the difference between the highest and the second highest Number of enrolments of both sexes in Poland?
Provide a succinct answer. 5.02e+04. What is the difference between the highest and the lowest Number of enrolments of both sexes in Other small states?
Provide a short and direct response. 3.69e+05. What is the difference between the highest and the lowest Number of enrolments of both sexes of Bahrain?
Provide a short and direct response. 8526. What is the difference between the highest and the lowest Number of enrolments of both sexes of Namibia?
Offer a very short reply. 5.92e+04. What is the difference between the highest and the lowest Number of enrolments of both sexes in Poland?
Offer a very short reply. 2.87e+05. 